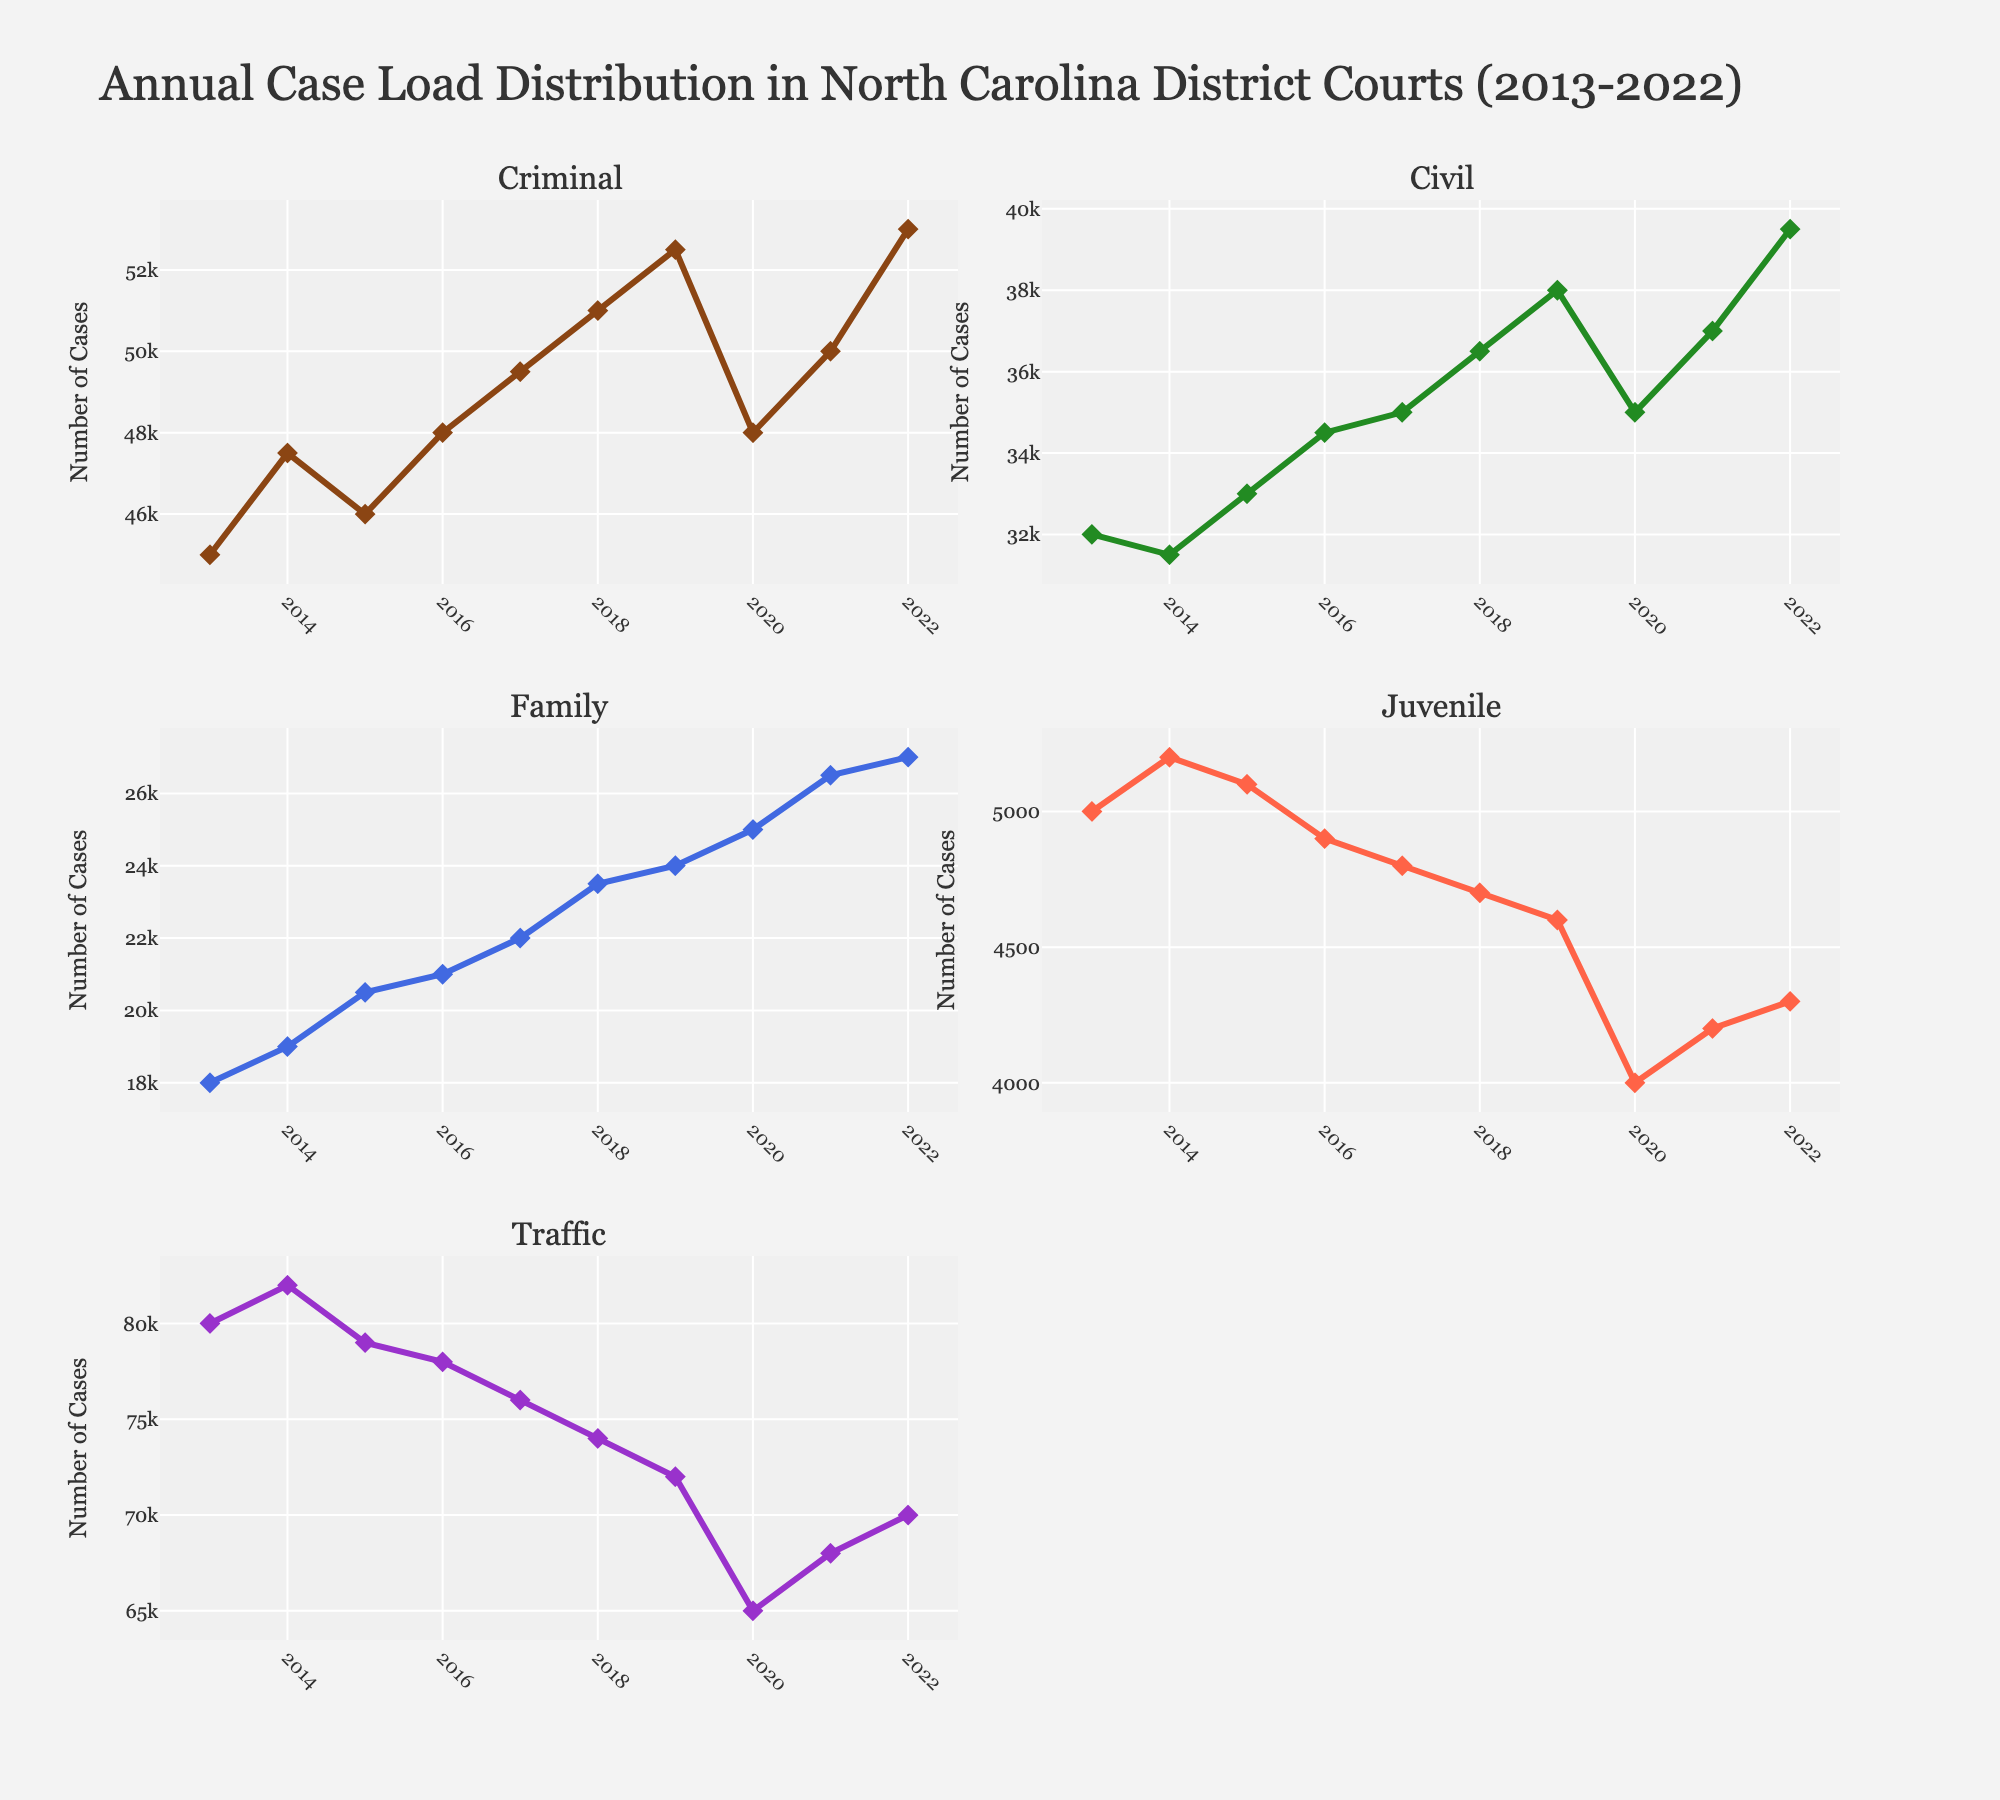Which case type has the highest number of cases in 2022? Look at the figure for the value of each case type in 2022. The Traffic subplot shows the highest value.
Answer: Traffic What's the overall trend for family cases from 2013 to 2022? Observe the Family subplot. The line generally increases over the years, indicating an upward trend.
Answer: Upward trend How does the number of criminal cases in 2020 compare to 2019? Check the Criminal subplot for the years 2019 and 2020. The number of cases in 2020 (48,000) is lower than in 2019 (52,500).
Answer: Lower in 2020 Which year had the highest number of juvenile cases? Look at the Juvenile subplot and find the peak value. The highest number of juvenile cases occurs in 2015.
Answer: 2015 What's the sum of civil and family cases in 2021? Find the number of civil cases (37,000) and family cases (26,500) in 2021 and sum them up. 37,000 + 26,500 = 63,500
Answer: 63,500 Which case types experienced a decrease in number from 2019 to 2020? Check each subplot for differences between 2019 and 2020. Criminal, Juvenile, and Traffic all show a decrease.
Answer: Criminal, Juvenile, Traffic What is the difference between the number of traffic and criminal cases in 2018? From the Traffic subplot, there are 74,000 cases. From the Criminal subplot, there are 51,000 cases. 74,000 - 51,000 = 23,000
Answer: 23,000 Is there any case type that had a constant or almost constant trend over the decade? Observe all subplots for any line that remains fairly constant. No case type shows a constant trend, but Juvenile cases show the least variation.
Answer: Juvenile (least variation) Which case type showed the sharpest decline in 2020 and by how much did it decline? Note the values for each case type in 2019 and 2020. Traffic cases decline the most, from 72,000 to 65,000. 72,000 - 65,000 = 7,000
Answer: Traffic, 7,000 